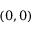Convert formula to latex. <formula><loc_0><loc_0><loc_500><loc_500>( 0 , 0 )</formula> 